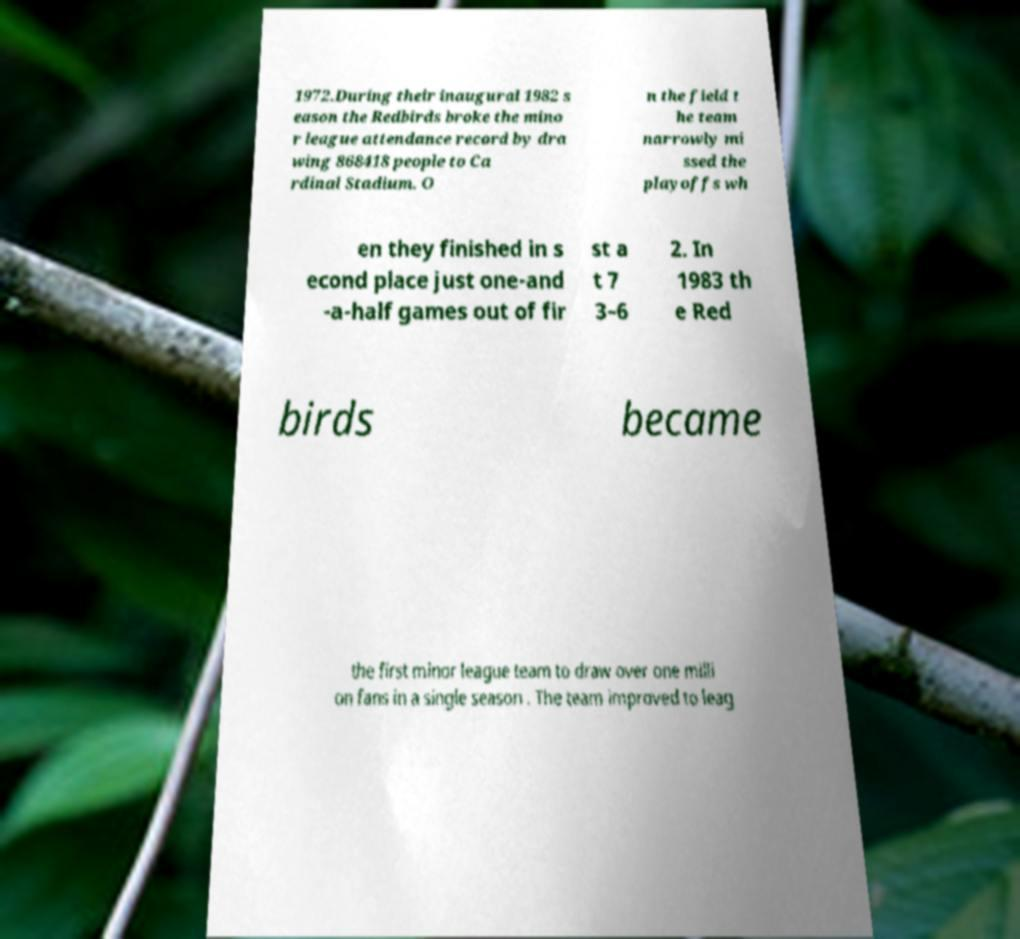Can you read and provide the text displayed in the image?This photo seems to have some interesting text. Can you extract and type it out for me? 1972.During their inaugural 1982 s eason the Redbirds broke the mino r league attendance record by dra wing 868418 people to Ca rdinal Stadium. O n the field t he team narrowly mi ssed the playoffs wh en they finished in s econd place just one-and -a-half games out of fir st a t 7 3–6 2. In 1983 th e Red birds became the first minor league team to draw over one milli on fans in a single season . The team improved to leag 